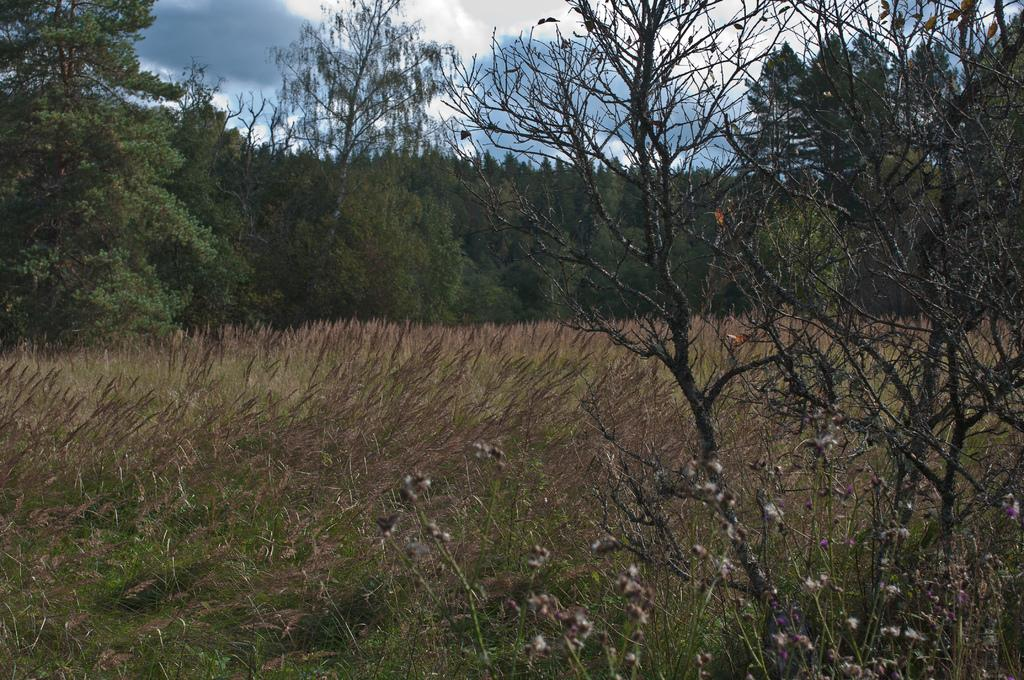What type of vegetation can be seen in the image? There are trees with branches and leaves in the image. What is the ground covered with in the image? There is dried grass visible in the image. What can be seen in the sky in the image? Clouds are present in the sky in the image. What type of joke is being told by the tree in the image? There is no joke being told by the tree in the image, as trees do not have the ability to tell jokes. 